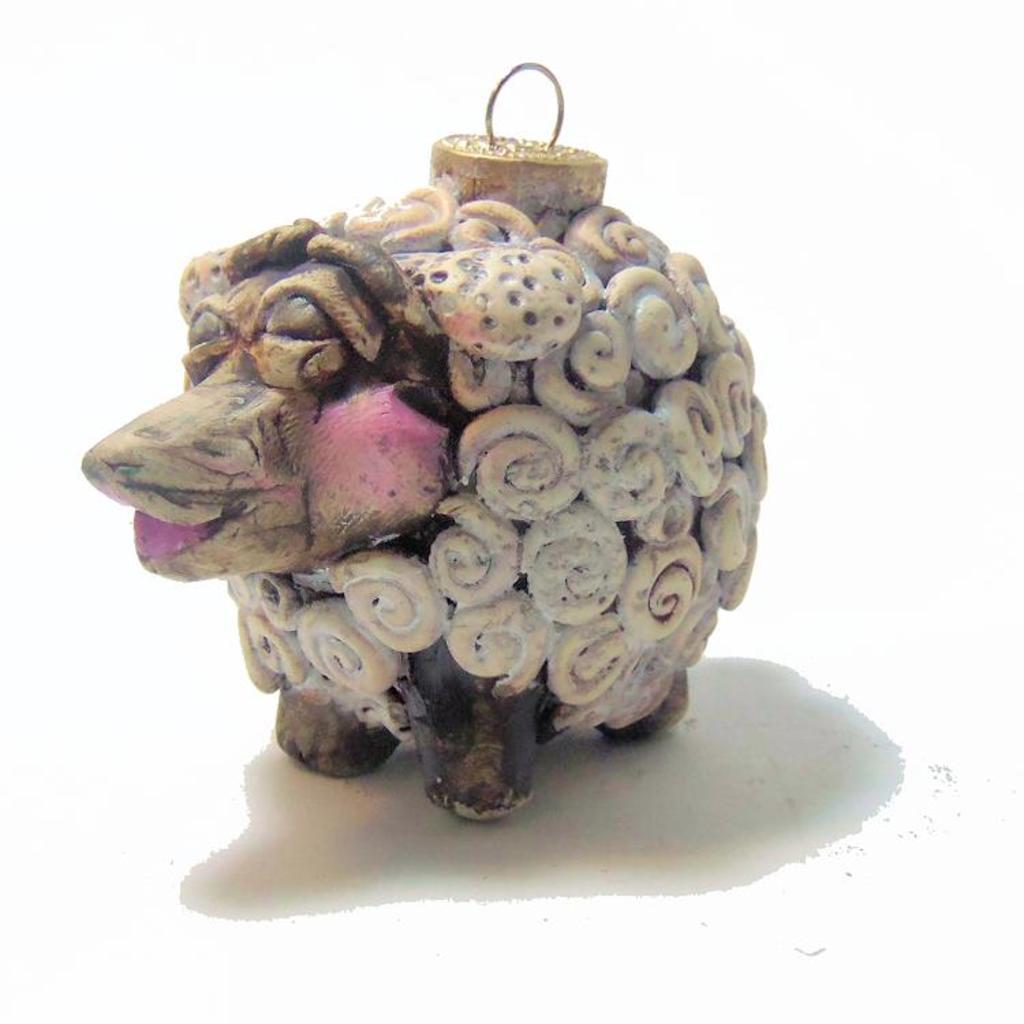In one or two sentences, can you explain what this image depicts? In this image we can see a toy. 